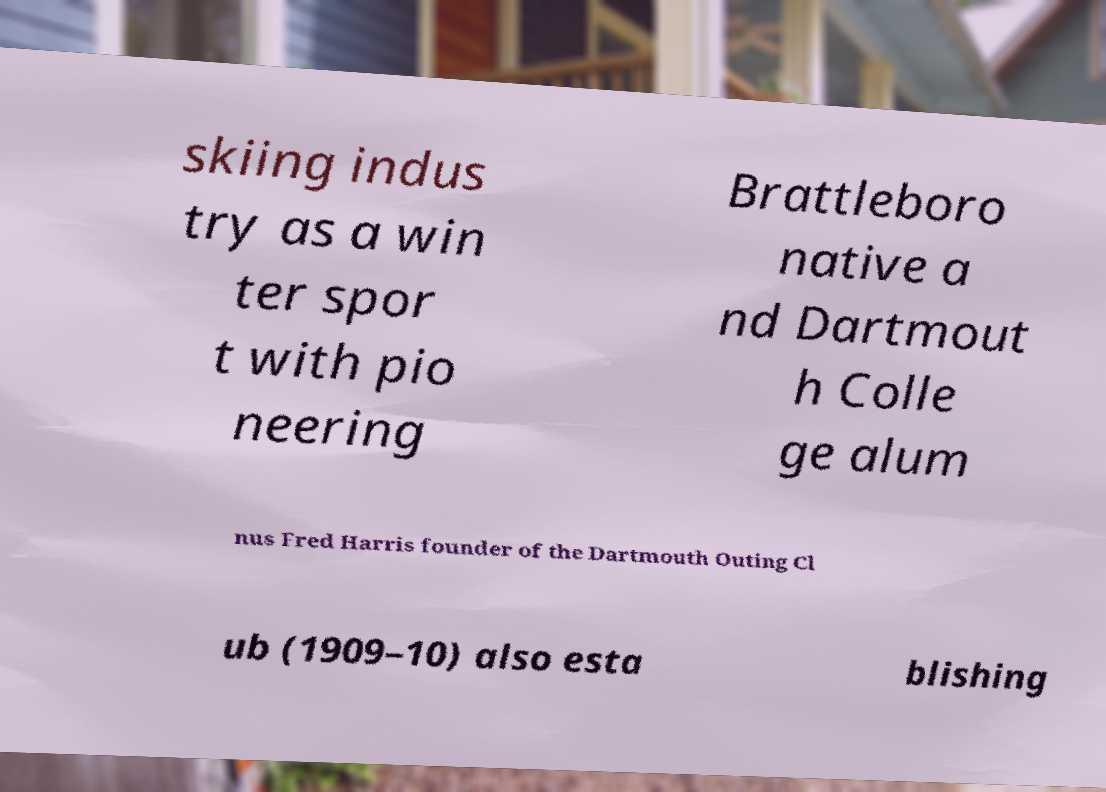Could you assist in decoding the text presented in this image and type it out clearly? skiing indus try as a win ter spor t with pio neering Brattleboro native a nd Dartmout h Colle ge alum nus Fred Harris founder of the Dartmouth Outing Cl ub (1909–10) also esta blishing 